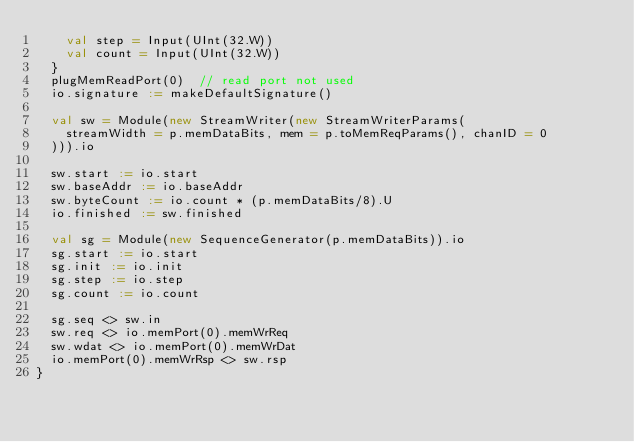<code> <loc_0><loc_0><loc_500><loc_500><_Scala_>    val step = Input(UInt(32.W))
    val count = Input(UInt(32.W))
  }
  plugMemReadPort(0)  // read port not used
  io.signature := makeDefaultSignature()

  val sw = Module(new StreamWriter(new StreamWriterParams(
    streamWidth = p.memDataBits, mem = p.toMemReqParams(), chanID = 0
  ))).io

  sw.start := io.start
  sw.baseAddr := io.baseAddr
  sw.byteCount := io.count * (p.memDataBits/8).U
  io.finished := sw.finished

  val sg = Module(new SequenceGenerator(p.memDataBits)).io
  sg.start := io.start
  sg.init := io.init
  sg.step := io.step
  sg.count := io.count

  sg.seq <> sw.in
  sw.req <> io.memPort(0).memWrReq
  sw.wdat <> io.memPort(0).memWrDat
  io.memPort(0).memWrRsp <> sw.rsp
}
</code> 